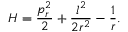Convert formula to latex. <formula><loc_0><loc_0><loc_500><loc_500>H = { \frac { p _ { r } ^ { 2 } } { 2 } } + { \frac { l ^ { 2 } } { 2 r ^ { 2 } } } - { \frac { 1 } { r } } .</formula> 